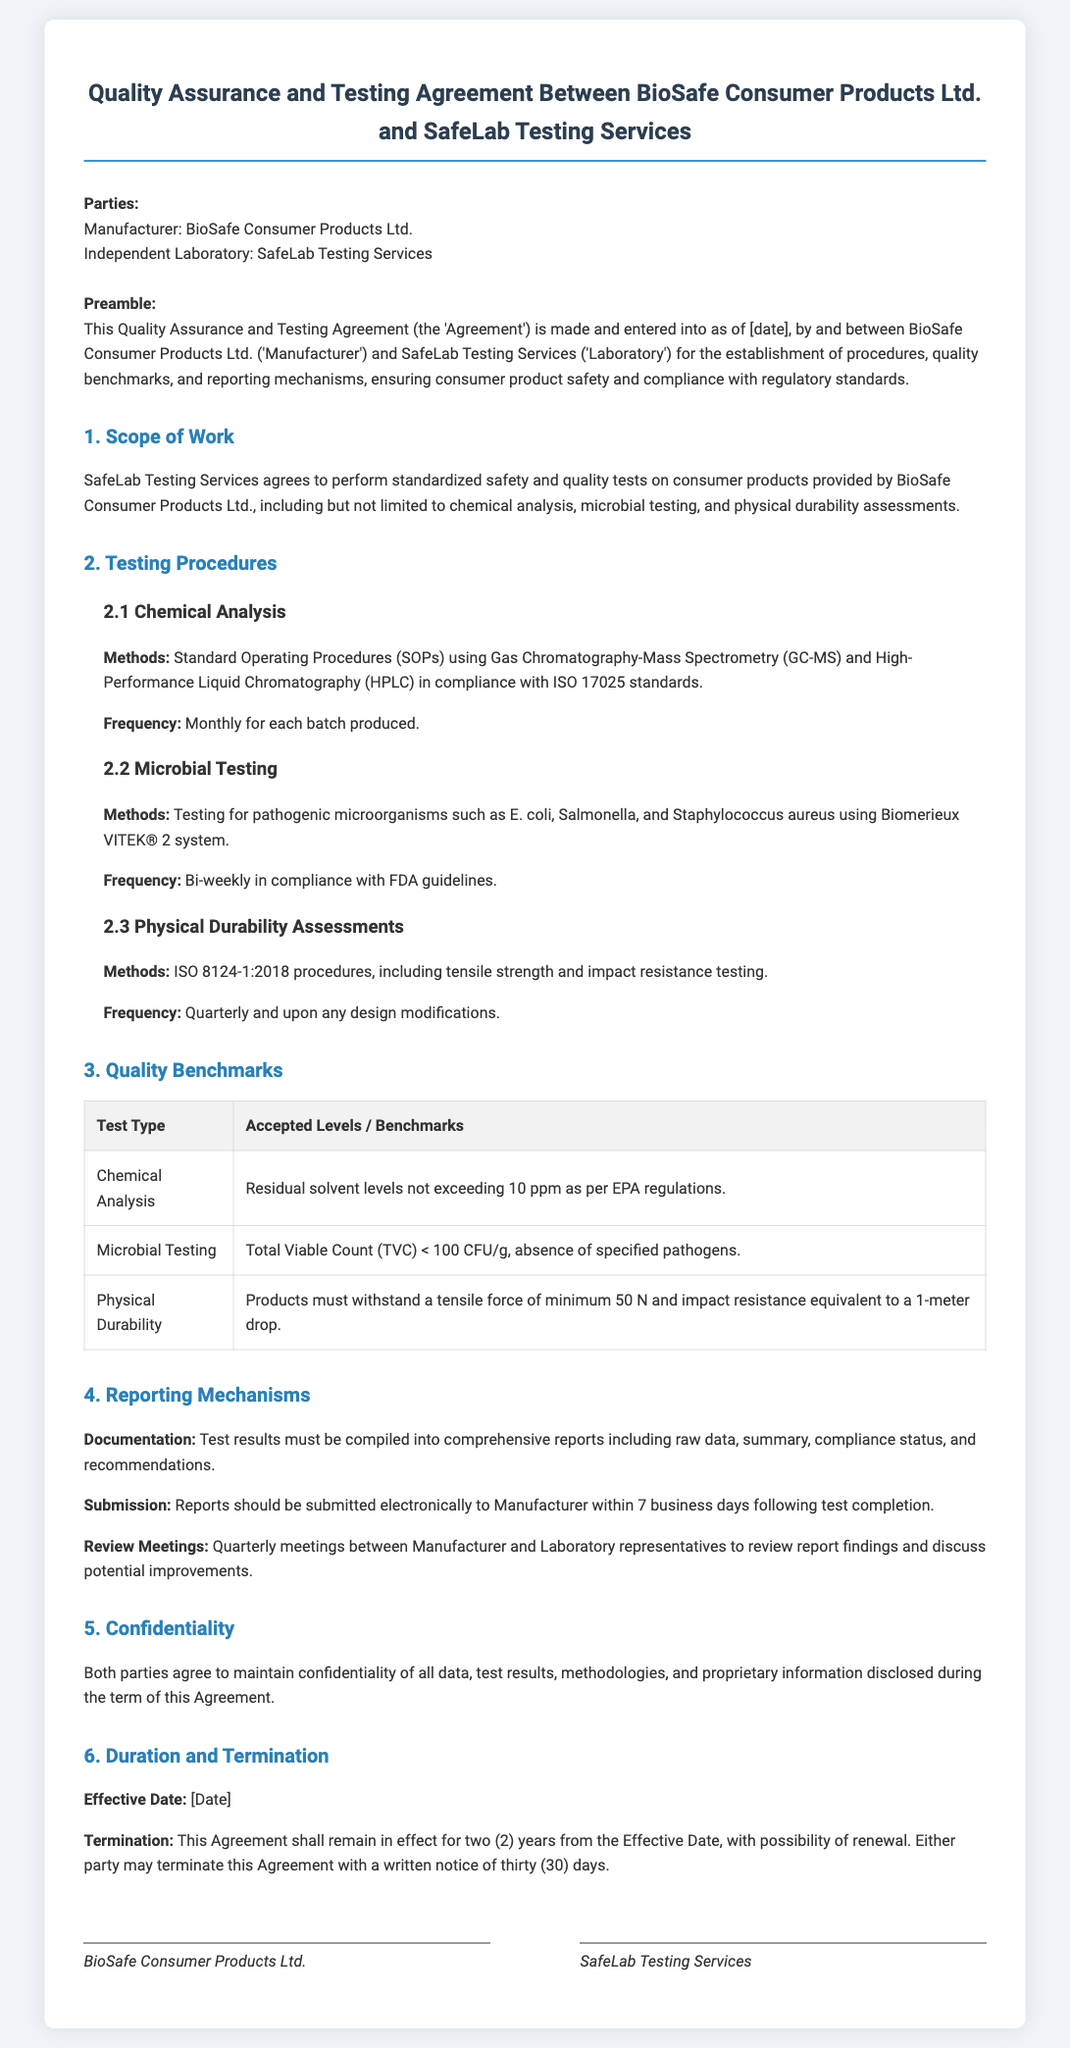what is the effective date of the Agreement? The effective date is mentioned within the duration and termination section, but is marked as [Date], indicating it needs to be filled in.
Answer: [Date] what type of testing is performed for Microbial Testing? The document specifies the methods used for microbial testing, which include testing for pathogenic microorganisms.
Answer: Pathogenic microorganisms how frequently are the Physical Durability Assessments conducted? The frequency of physical durability assessments is outlined in the testing procedures section, stating they occur quarterly and upon design modifications.
Answer: Quarterly and upon any design modifications what is the maximum accepted level for residual solvent in Chemical Analysis? This level is specified in the quality benchmarks table, indicating regulatory compliance.
Answer: 10 ppm how long is the Agreement effective? The duration of the Agreement is specified in the section detailing duration and termination.
Answer: Two years what must the reports include according to the Reporting Mechanisms? The reports requirements are outlined as including raw data, summary, compliance status, and recommendations.
Answer: Raw data, summary, compliance status, recommendations which two parties are involved in this Agreement? The document clearly states the parties involved in the introduction section.
Answer: BioSafe Consumer Products Ltd. and SafeLab Testing Services what is the absence of specified pathogens as per the benchmark for Microbial Testing? This benchmark is mentioned in the quality benchmarks table and refers to microbial testing results.
Answer: Absence of specified pathogens what must be done if either party wants to terminate the Agreement? The document specifies the procedure for termination within the duration section.
Answer: Written notice of thirty days 